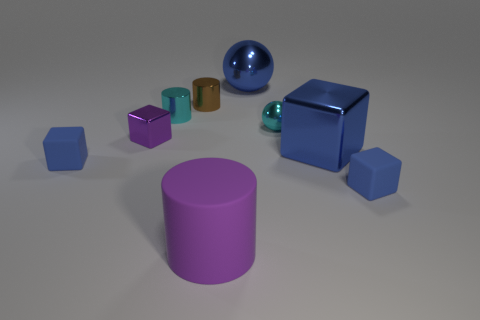How many blue blocks must be subtracted to get 1 blue blocks? 2 Subtract all large cubes. How many cubes are left? 3 Subtract all purple blocks. How many blocks are left? 3 Subtract all blue cylinders. How many cyan spheres are left? 1 Subtract 1 cylinders. How many cylinders are left? 2 Subtract all gray cylinders. Subtract all cyan spheres. How many cylinders are left? 3 Subtract all cyan objects. Subtract all large purple matte cylinders. How many objects are left? 6 Add 3 large purple things. How many large purple things are left? 4 Add 1 tiny yellow rubber things. How many tiny yellow rubber things exist? 1 Subtract 0 brown blocks. How many objects are left? 9 